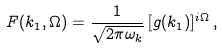<formula> <loc_0><loc_0><loc_500><loc_500>F ( k _ { 1 } , \Omega ) = \frac { 1 } { \sqrt { 2 \pi \omega _ { k } } } \, [ g ( k _ { 1 } ) ] ^ { i \Omega } \, ,</formula> 